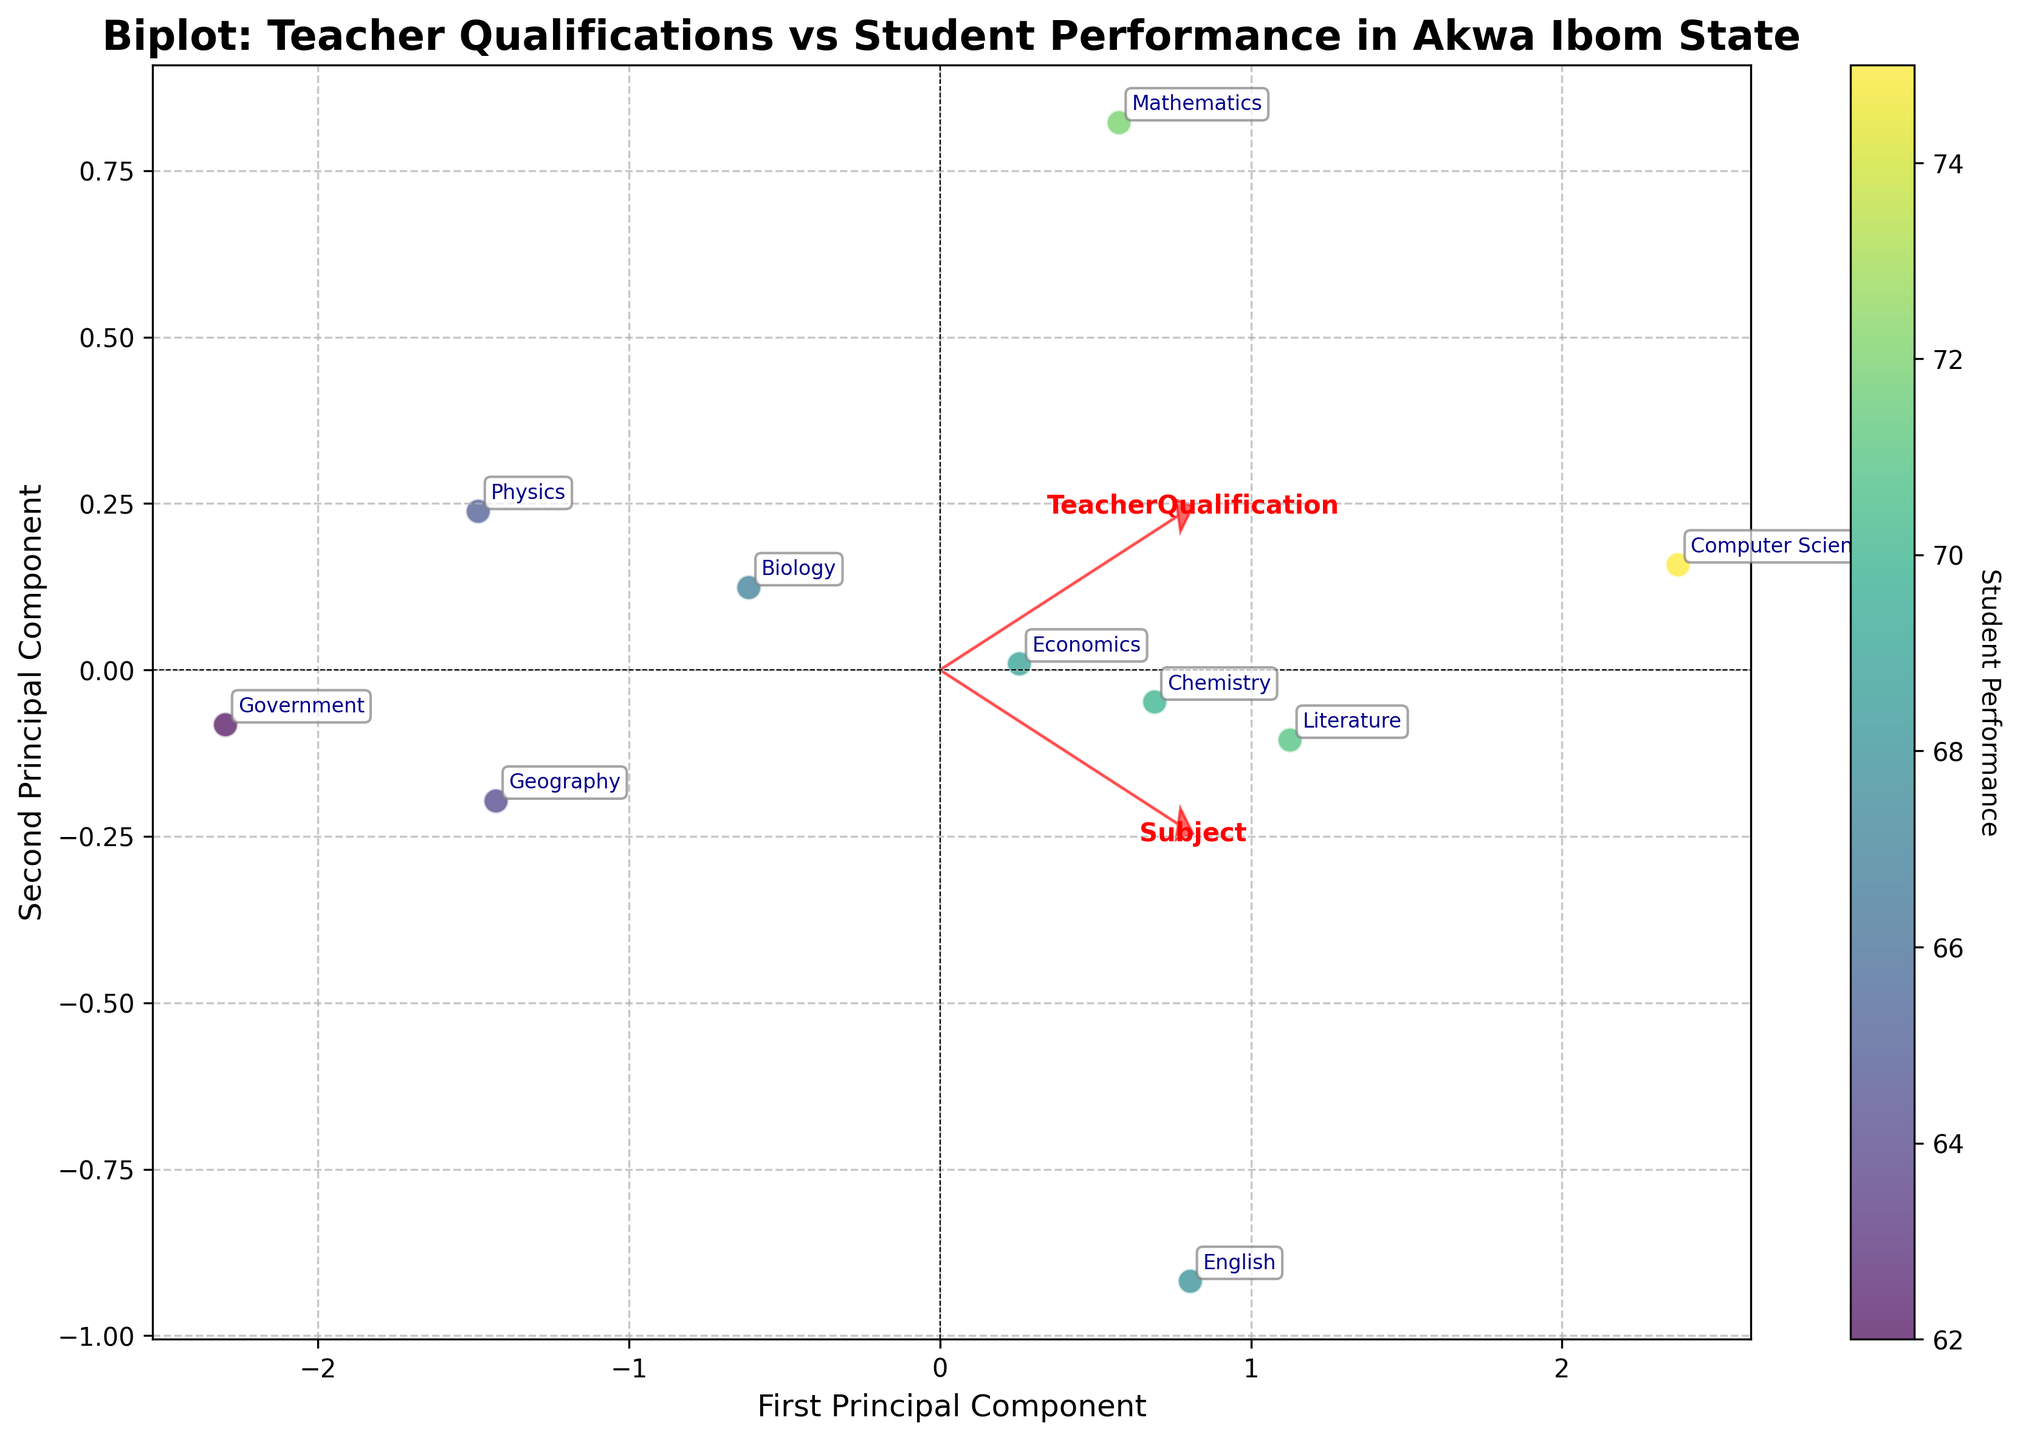What is the title of the figure? The title of a figure is usually prominently displayed at the top to provide a quick understanding of the subject matter. Here, it's mentioned at the top center as "Biplot: Teacher Qualifications vs Student Performance in Akwa Ibom State."
Answer: Biplot: Teacher Qualifications vs Student Performance in Akwa Ibom State How many principal components are shown in the biplot? Biplots typically display two principal components, represented by the axes on the figure, labeled as "First Principal Component" and "Second Principal Component."
Answer: Two Which subject has the highest student performance? Identify the data point with the highest value on the color bar indicating "Student Performance." Here, the highest performance score is 75 for "Computer Science."
Answer: Computer Science What is the relationship between "Teacher Qualification" and the "First Principal Component"? The projection of the vectors from the origin gives a sense of correlation. The "Teacher Qualification" vector's length and direction in relation to the first principal component axis indicate a strong correlation.
Answer: Strong correlation Which subject is closest to the origin of the biplot? By inspecting the plot, locate the subject label that is closest to where the two principal component axes intersect (origin). Here, "Physics" is near the origin.
Answer: Physics Does "Teacher Qualification" have a stronger correlation with the first or second principal component? Observe the alignment of "Teacher Qualification" vector with respect to the axes of the principal components. The length and direction towards the first principal component indicate a stronger correlation there.
Answer: First Principal Component What general trend can you observe between "Teacher Qualification" and "Student Performance"? Examine the overall direction and length of the vectors for both "Teacher Qualification" and "Student Performance" in the biplot. Both generally point in a similar direction, indicating that higher teacher qualifications tend to correlate with better student performance.
Answer: Positive correlation Which subject has the closest average performance to English? Locate the position of English in the biplot and identify the subject closest in position. This visualization shows "Economics" as the closest to "English" in terms of performance.
Answer: Economics What does the color intensity in each marker represent? The color bar on the side of the plot indicates the range of colors and their corresponding "Student Performance" values, with high values having darker colors and vice versa.
Answer: Student Performance 